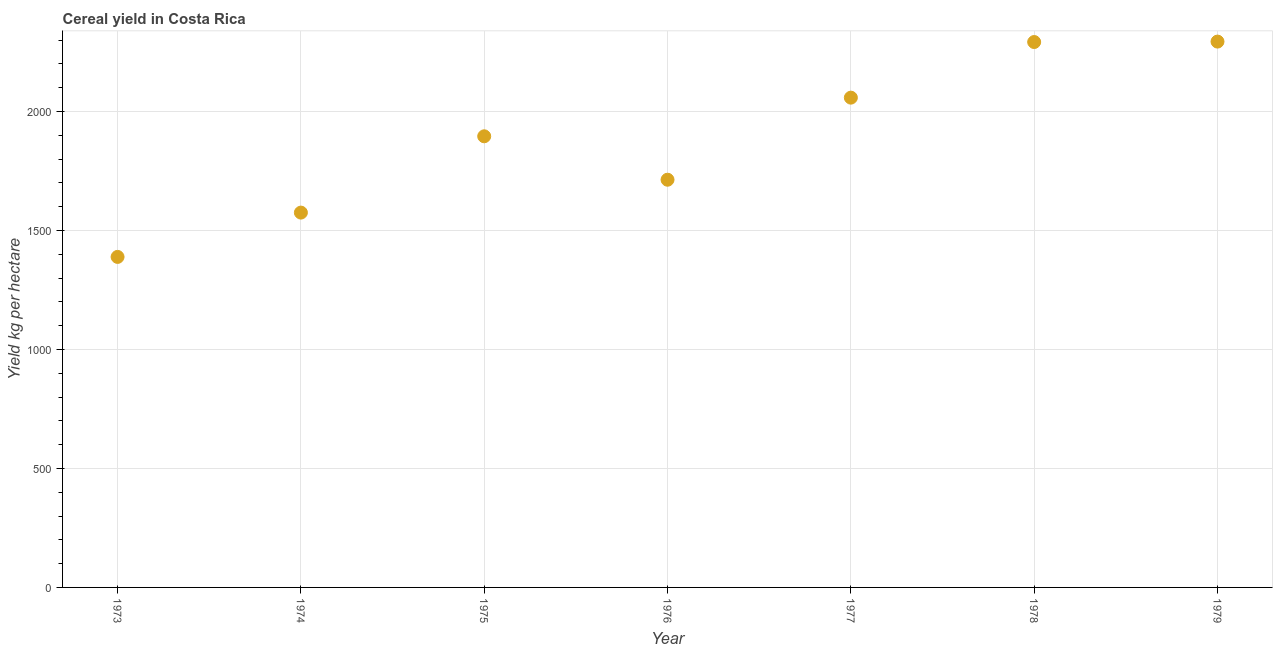What is the cereal yield in 1973?
Ensure brevity in your answer.  1388.81. Across all years, what is the maximum cereal yield?
Your answer should be very brief. 2293.55. Across all years, what is the minimum cereal yield?
Your answer should be compact. 1388.81. In which year was the cereal yield maximum?
Your answer should be very brief. 1979. In which year was the cereal yield minimum?
Offer a terse response. 1973. What is the sum of the cereal yield?
Ensure brevity in your answer.  1.32e+04. What is the difference between the cereal yield in 1975 and 1976?
Provide a short and direct response. 182.5. What is the average cereal yield per year?
Make the answer very short. 1887.98. What is the median cereal yield?
Provide a short and direct response. 1895.63. Do a majority of the years between 1979 and 1973 (inclusive) have cereal yield greater than 600 kg per hectare?
Your answer should be compact. Yes. What is the ratio of the cereal yield in 1974 to that in 1979?
Give a very brief answer. 0.69. Is the cereal yield in 1978 less than that in 1979?
Offer a very short reply. Yes. What is the difference between the highest and the second highest cereal yield?
Give a very brief answer. 1.85. Is the sum of the cereal yield in 1976 and 1977 greater than the maximum cereal yield across all years?
Provide a succinct answer. Yes. What is the difference between the highest and the lowest cereal yield?
Offer a terse response. 904.75. In how many years, is the cereal yield greater than the average cereal yield taken over all years?
Your answer should be very brief. 4. How many years are there in the graph?
Give a very brief answer. 7. Are the values on the major ticks of Y-axis written in scientific E-notation?
Make the answer very short. No. Does the graph contain grids?
Ensure brevity in your answer.  Yes. What is the title of the graph?
Ensure brevity in your answer.  Cereal yield in Costa Rica. What is the label or title of the Y-axis?
Give a very brief answer. Yield kg per hectare. What is the Yield kg per hectare in 1973?
Your response must be concise. 1388.81. What is the Yield kg per hectare in 1974?
Offer a very short reply. 1574.99. What is the Yield kg per hectare in 1975?
Your response must be concise. 1895.63. What is the Yield kg per hectare in 1976?
Keep it short and to the point. 1713.14. What is the Yield kg per hectare in 1977?
Your answer should be compact. 2058.03. What is the Yield kg per hectare in 1978?
Your answer should be very brief. 2291.7. What is the Yield kg per hectare in 1979?
Keep it short and to the point. 2293.55. What is the difference between the Yield kg per hectare in 1973 and 1974?
Offer a terse response. -186.19. What is the difference between the Yield kg per hectare in 1973 and 1975?
Offer a very short reply. -506.83. What is the difference between the Yield kg per hectare in 1973 and 1976?
Your answer should be compact. -324.33. What is the difference between the Yield kg per hectare in 1973 and 1977?
Offer a terse response. -669.22. What is the difference between the Yield kg per hectare in 1973 and 1978?
Your answer should be very brief. -902.89. What is the difference between the Yield kg per hectare in 1973 and 1979?
Your response must be concise. -904.75. What is the difference between the Yield kg per hectare in 1974 and 1975?
Give a very brief answer. -320.64. What is the difference between the Yield kg per hectare in 1974 and 1976?
Provide a succinct answer. -138.15. What is the difference between the Yield kg per hectare in 1974 and 1977?
Make the answer very short. -483.03. What is the difference between the Yield kg per hectare in 1974 and 1978?
Ensure brevity in your answer.  -716.71. What is the difference between the Yield kg per hectare in 1974 and 1979?
Your answer should be very brief. -718.56. What is the difference between the Yield kg per hectare in 1975 and 1976?
Provide a succinct answer. 182.5. What is the difference between the Yield kg per hectare in 1975 and 1977?
Your answer should be very brief. -162.39. What is the difference between the Yield kg per hectare in 1975 and 1978?
Your response must be concise. -396.07. What is the difference between the Yield kg per hectare in 1975 and 1979?
Provide a short and direct response. -397.92. What is the difference between the Yield kg per hectare in 1976 and 1977?
Make the answer very short. -344.89. What is the difference between the Yield kg per hectare in 1976 and 1978?
Make the answer very short. -578.57. What is the difference between the Yield kg per hectare in 1976 and 1979?
Provide a succinct answer. -580.42. What is the difference between the Yield kg per hectare in 1977 and 1978?
Your answer should be very brief. -233.68. What is the difference between the Yield kg per hectare in 1977 and 1979?
Make the answer very short. -235.53. What is the difference between the Yield kg per hectare in 1978 and 1979?
Your answer should be very brief. -1.85. What is the ratio of the Yield kg per hectare in 1973 to that in 1974?
Your response must be concise. 0.88. What is the ratio of the Yield kg per hectare in 1973 to that in 1975?
Your answer should be compact. 0.73. What is the ratio of the Yield kg per hectare in 1973 to that in 1976?
Your response must be concise. 0.81. What is the ratio of the Yield kg per hectare in 1973 to that in 1977?
Offer a very short reply. 0.68. What is the ratio of the Yield kg per hectare in 1973 to that in 1978?
Provide a short and direct response. 0.61. What is the ratio of the Yield kg per hectare in 1973 to that in 1979?
Provide a short and direct response. 0.61. What is the ratio of the Yield kg per hectare in 1974 to that in 1975?
Ensure brevity in your answer.  0.83. What is the ratio of the Yield kg per hectare in 1974 to that in 1976?
Your response must be concise. 0.92. What is the ratio of the Yield kg per hectare in 1974 to that in 1977?
Ensure brevity in your answer.  0.77. What is the ratio of the Yield kg per hectare in 1974 to that in 1978?
Offer a very short reply. 0.69. What is the ratio of the Yield kg per hectare in 1974 to that in 1979?
Provide a short and direct response. 0.69. What is the ratio of the Yield kg per hectare in 1975 to that in 1976?
Your response must be concise. 1.11. What is the ratio of the Yield kg per hectare in 1975 to that in 1977?
Your answer should be compact. 0.92. What is the ratio of the Yield kg per hectare in 1975 to that in 1978?
Make the answer very short. 0.83. What is the ratio of the Yield kg per hectare in 1975 to that in 1979?
Ensure brevity in your answer.  0.83. What is the ratio of the Yield kg per hectare in 1976 to that in 1977?
Keep it short and to the point. 0.83. What is the ratio of the Yield kg per hectare in 1976 to that in 1978?
Offer a very short reply. 0.75. What is the ratio of the Yield kg per hectare in 1976 to that in 1979?
Offer a very short reply. 0.75. What is the ratio of the Yield kg per hectare in 1977 to that in 1978?
Your answer should be very brief. 0.9. What is the ratio of the Yield kg per hectare in 1977 to that in 1979?
Make the answer very short. 0.9. What is the ratio of the Yield kg per hectare in 1978 to that in 1979?
Your answer should be very brief. 1. 